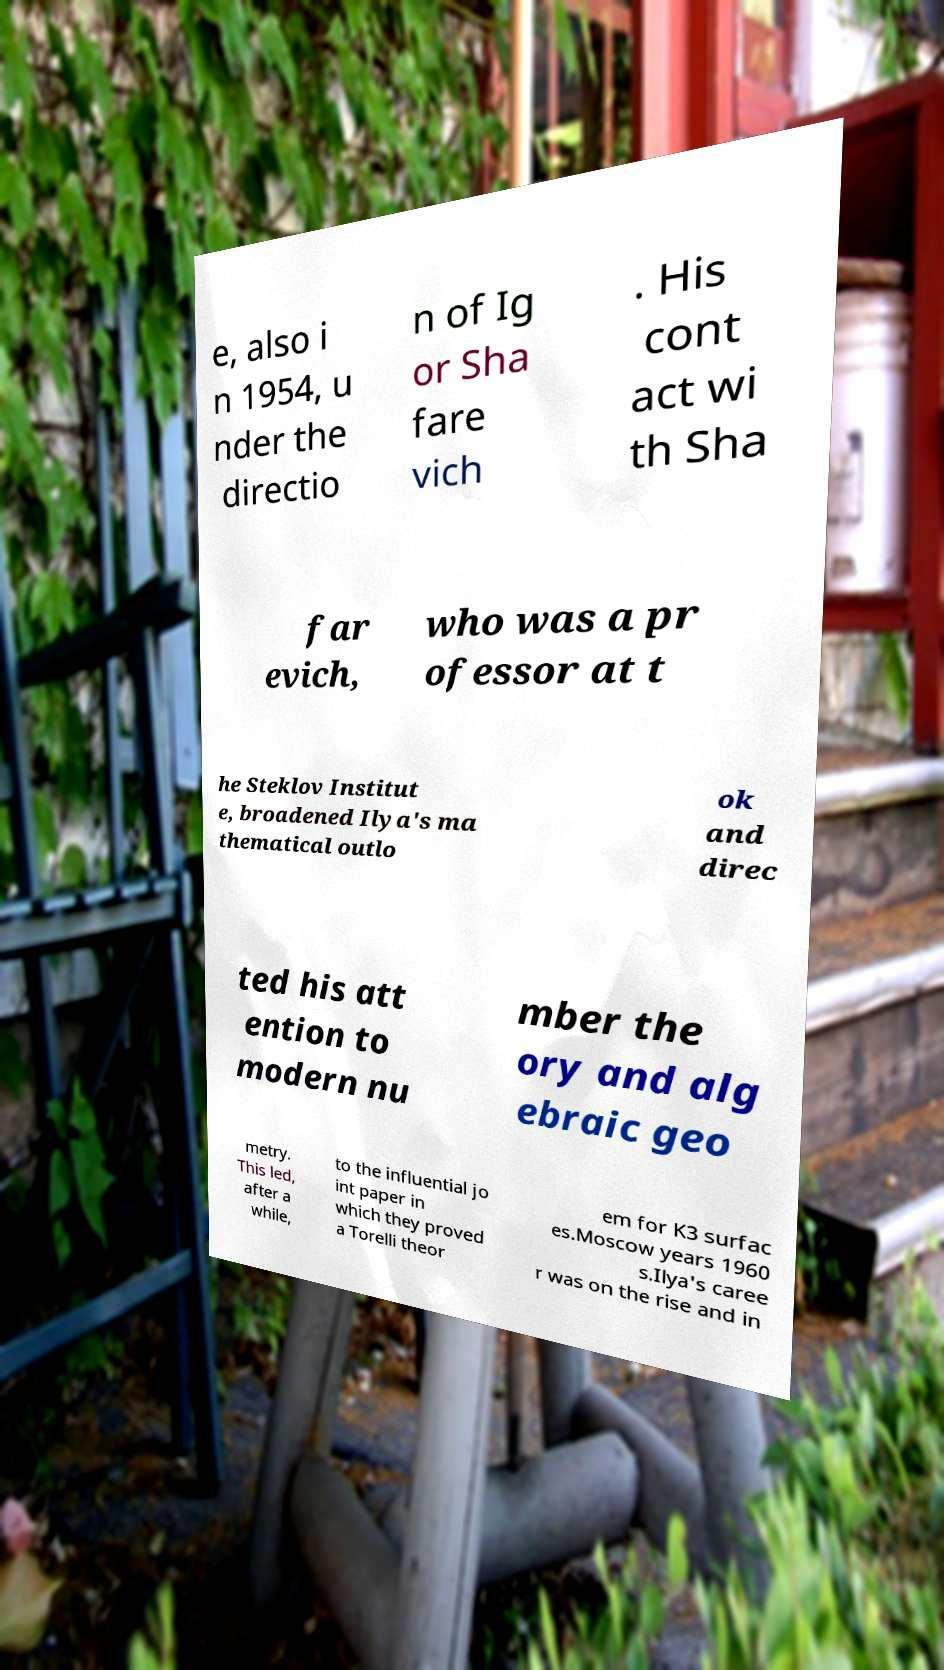There's text embedded in this image that I need extracted. Can you transcribe it verbatim? e, also i n 1954, u nder the directio n of Ig or Sha fare vich . His cont act wi th Sha far evich, who was a pr ofessor at t he Steklov Institut e, broadened Ilya's ma thematical outlo ok and direc ted his att ention to modern nu mber the ory and alg ebraic geo metry. This led, after a while, to the influential jo int paper in which they proved a Torelli theor em for K3 surfac es.Moscow years 1960 s.Ilya's caree r was on the rise and in 